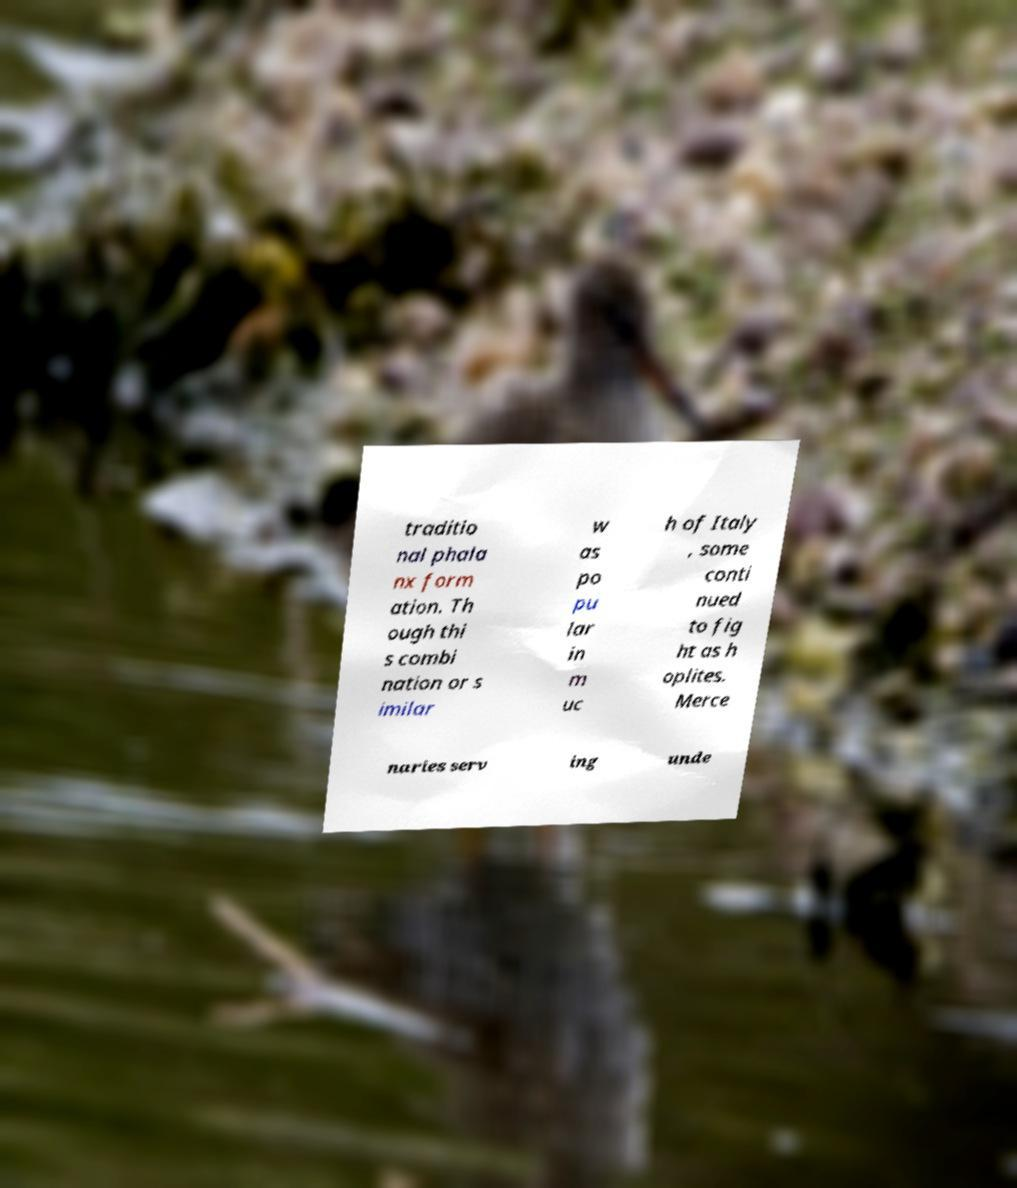Please identify and transcribe the text found in this image. traditio nal phala nx form ation. Th ough thi s combi nation or s imilar w as po pu lar in m uc h of Italy , some conti nued to fig ht as h oplites. Merce naries serv ing unde 